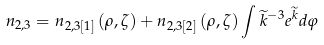<formula> <loc_0><loc_0><loc_500><loc_500>n _ { 2 , 3 } = n _ { 2 , 3 [ 1 ] } \left ( \rho , \zeta \right ) + n _ { 2 , 3 [ 2 ] } \left ( \rho , \zeta \right ) \int \widetilde { k } ^ { - 3 } e ^ { \widetilde { k } } d \varphi</formula> 